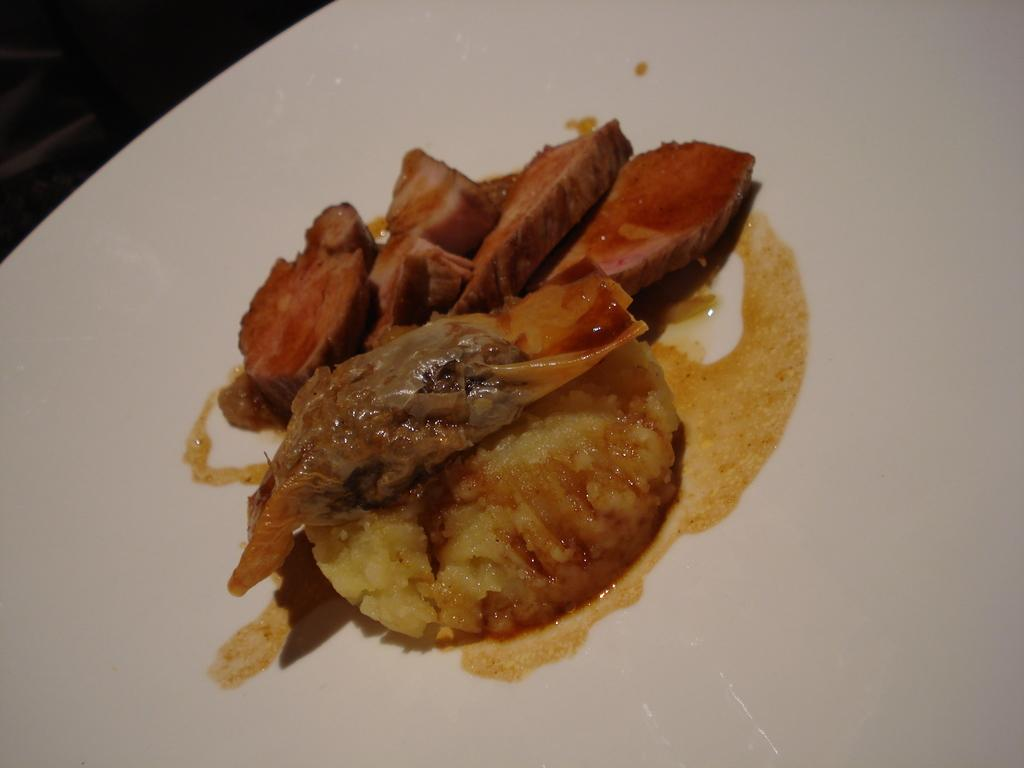What is on the plate that is visible in the image? There is food on a plate in the image. What color is the plate? The plate is white. How many ornaments are hanging from the plate in the image? There are no ornaments hanging from the plate in the image. What type of baby food can be seen on the plate? There is no baby food present in the image, as it only features food on a white plate. 